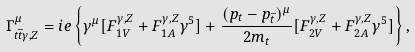Convert formula to latex. <formula><loc_0><loc_0><loc_500><loc_500>\Gamma ^ { \mu } _ { t \bar { t } \gamma , Z } = i e \left \{ \gamma ^ { \mu } [ F ^ { \gamma , Z } _ { 1 V } + F ^ { \gamma , Z } _ { 1 A } \gamma ^ { 5 } ] + \frac { ( p _ { t } - p _ { \bar { t } } ) ^ { \mu } } { 2 m _ { t } } [ F ^ { \gamma , Z } _ { 2 V } + F ^ { \gamma , Z } _ { 2 A } \gamma ^ { 5 } ] \right \} ,</formula> 